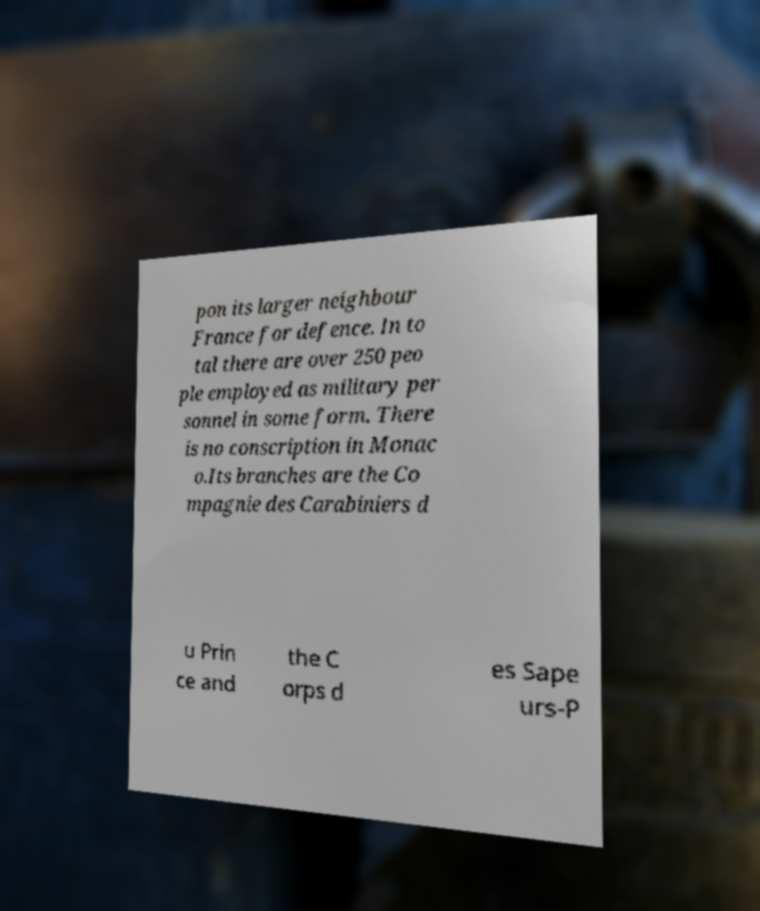What messages or text are displayed in this image? I need them in a readable, typed format. pon its larger neighbour France for defence. In to tal there are over 250 peo ple employed as military per sonnel in some form. There is no conscription in Monac o.Its branches are the Co mpagnie des Carabiniers d u Prin ce and the C orps d es Sape urs-P 